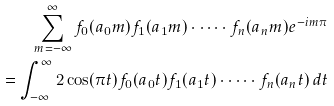Convert formula to latex. <formula><loc_0><loc_0><loc_500><loc_500>\sum _ { m = - \infty } ^ { \infty } f _ { 0 } ( a _ { 0 } m ) f _ { 1 } ( a _ { 1 } m ) \cdot \dots \cdot f _ { n } ( a _ { n } m ) e ^ { - i m \pi } \\ = \int _ { - \infty } ^ { \infty } 2 \cos ( \pi t ) f _ { 0 } ( a _ { 0 } t ) f _ { 1 } ( a _ { 1 } t ) \cdot \dots \cdot f _ { n } ( a _ { n } t ) \, d t</formula> 